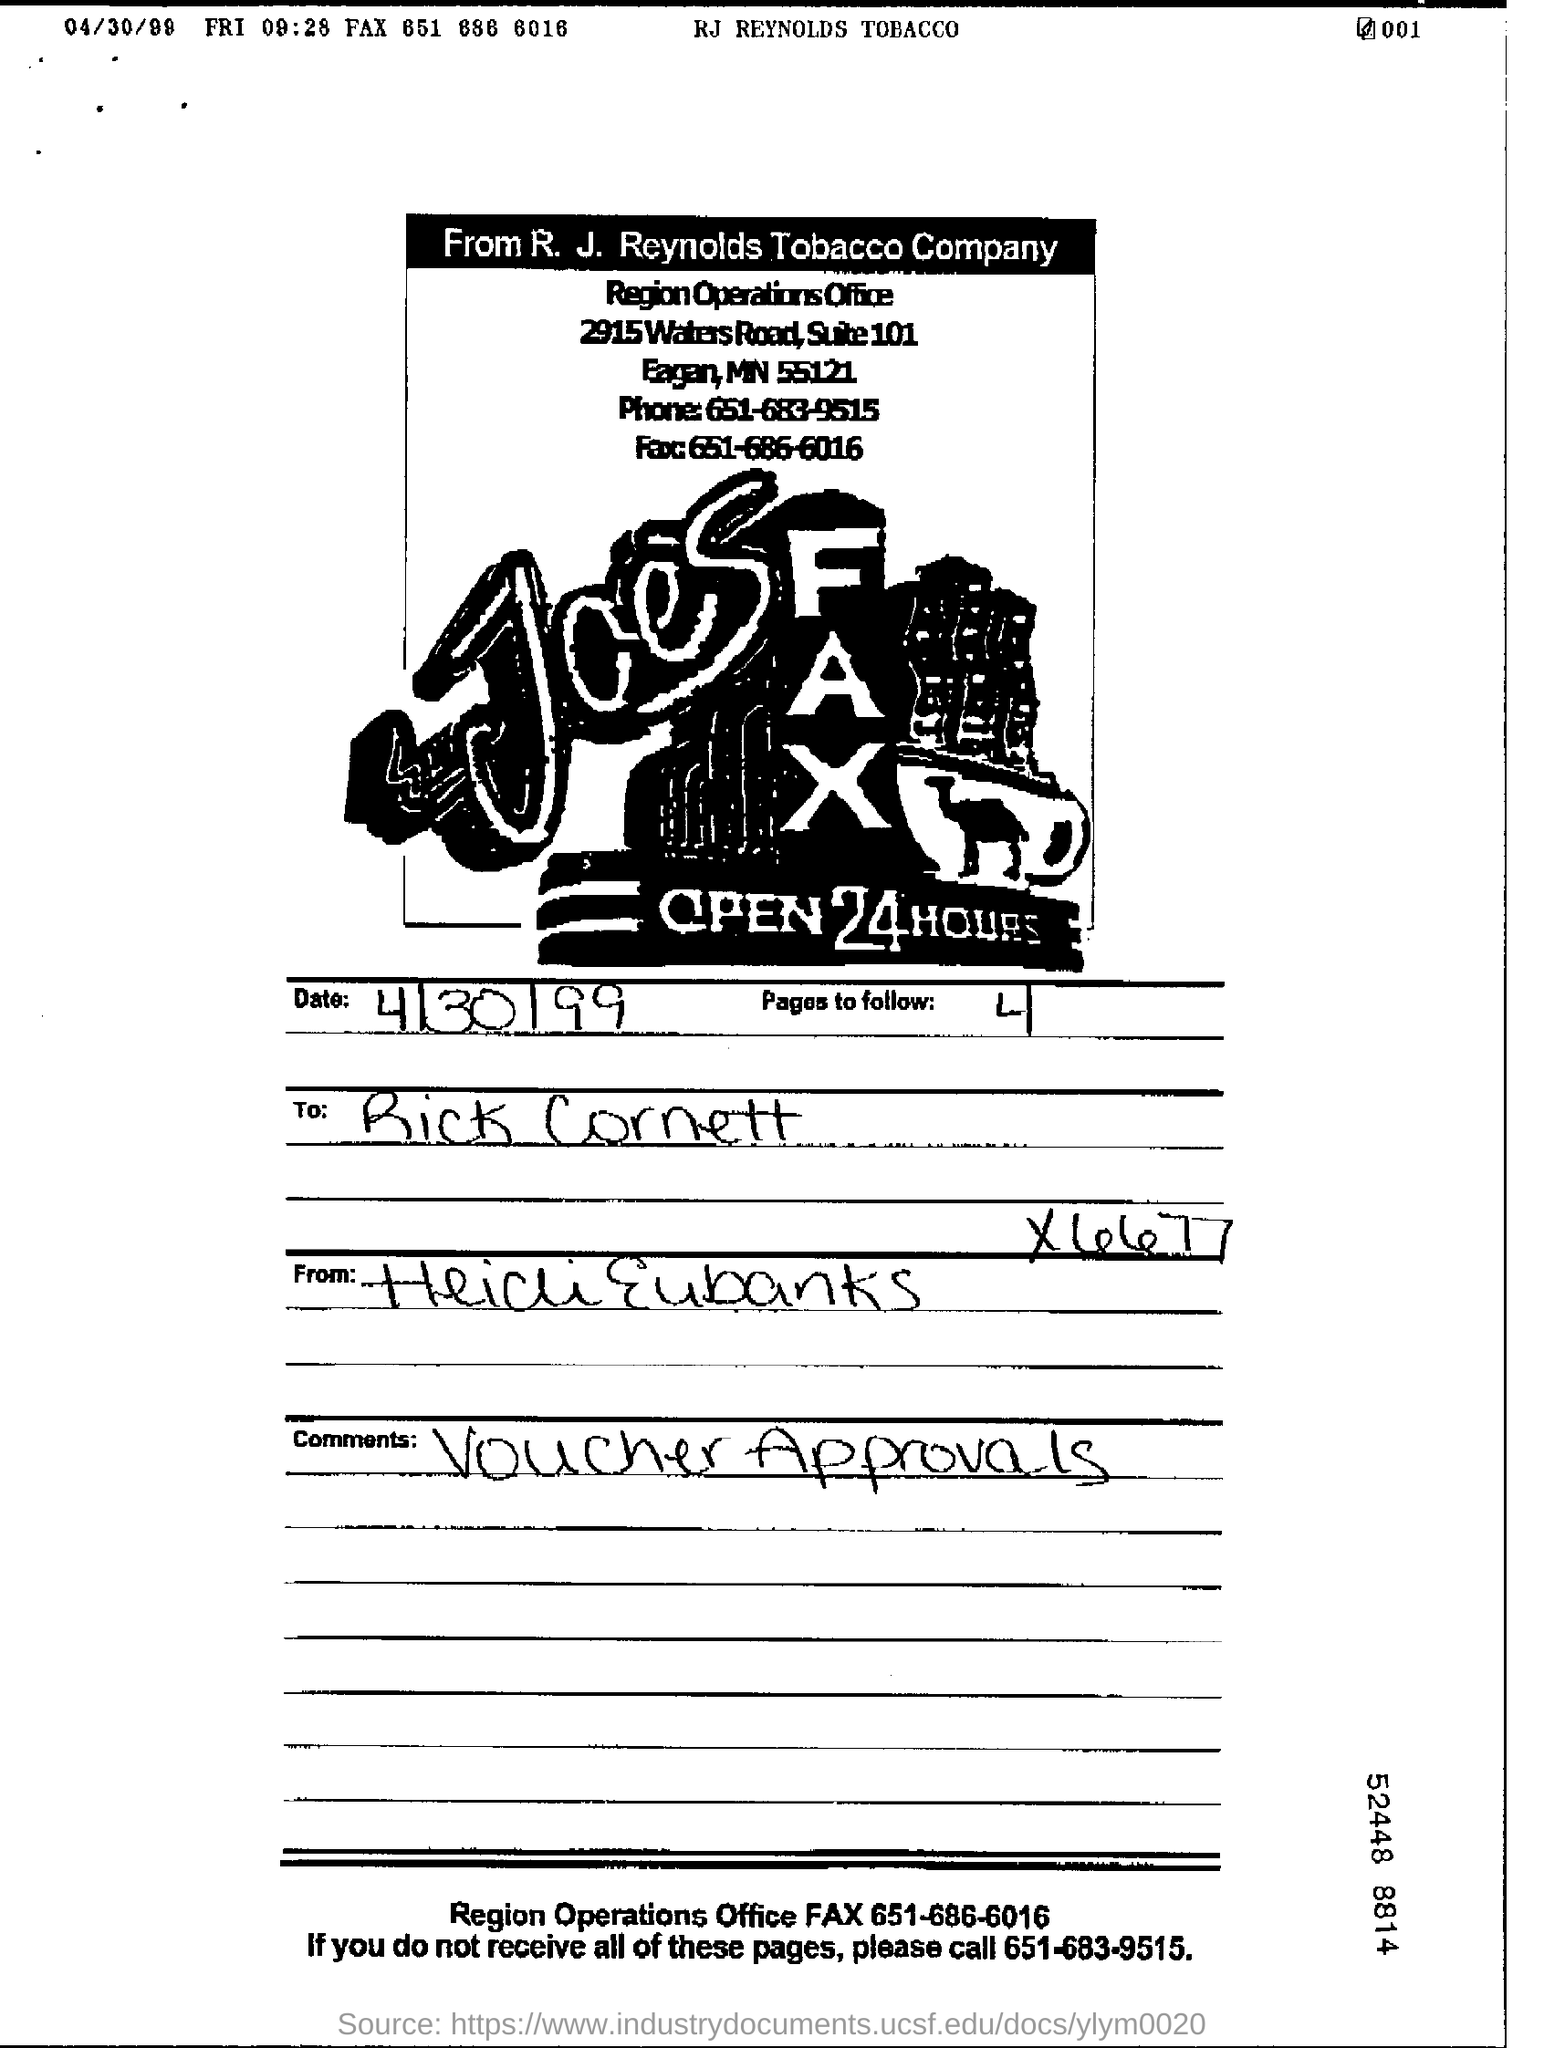Identify some key points in this picture. The document is dated April 30, 1999. The written comments received are for voucher approvals. The Region Operations Office FAX number is 651-686-6016. After following 4 pages, how many pages should I follow? 